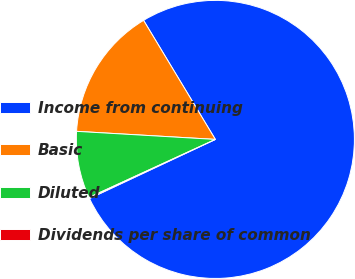Convert chart. <chart><loc_0><loc_0><loc_500><loc_500><pie_chart><fcel>Income from continuing<fcel>Basic<fcel>Diluted<fcel>Dividends per share of common<nl><fcel>76.65%<fcel>15.44%<fcel>7.78%<fcel>0.13%<nl></chart> 